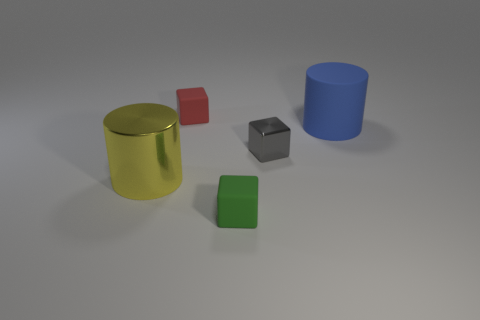Add 3 small cyan cylinders. How many objects exist? 8 Subtract all cubes. How many objects are left? 2 Add 2 big yellow cylinders. How many big yellow cylinders exist? 3 Subtract 0 green cylinders. How many objects are left? 5 Subtract all blocks. Subtract all big brown rubber cylinders. How many objects are left? 2 Add 5 small green things. How many small green things are left? 6 